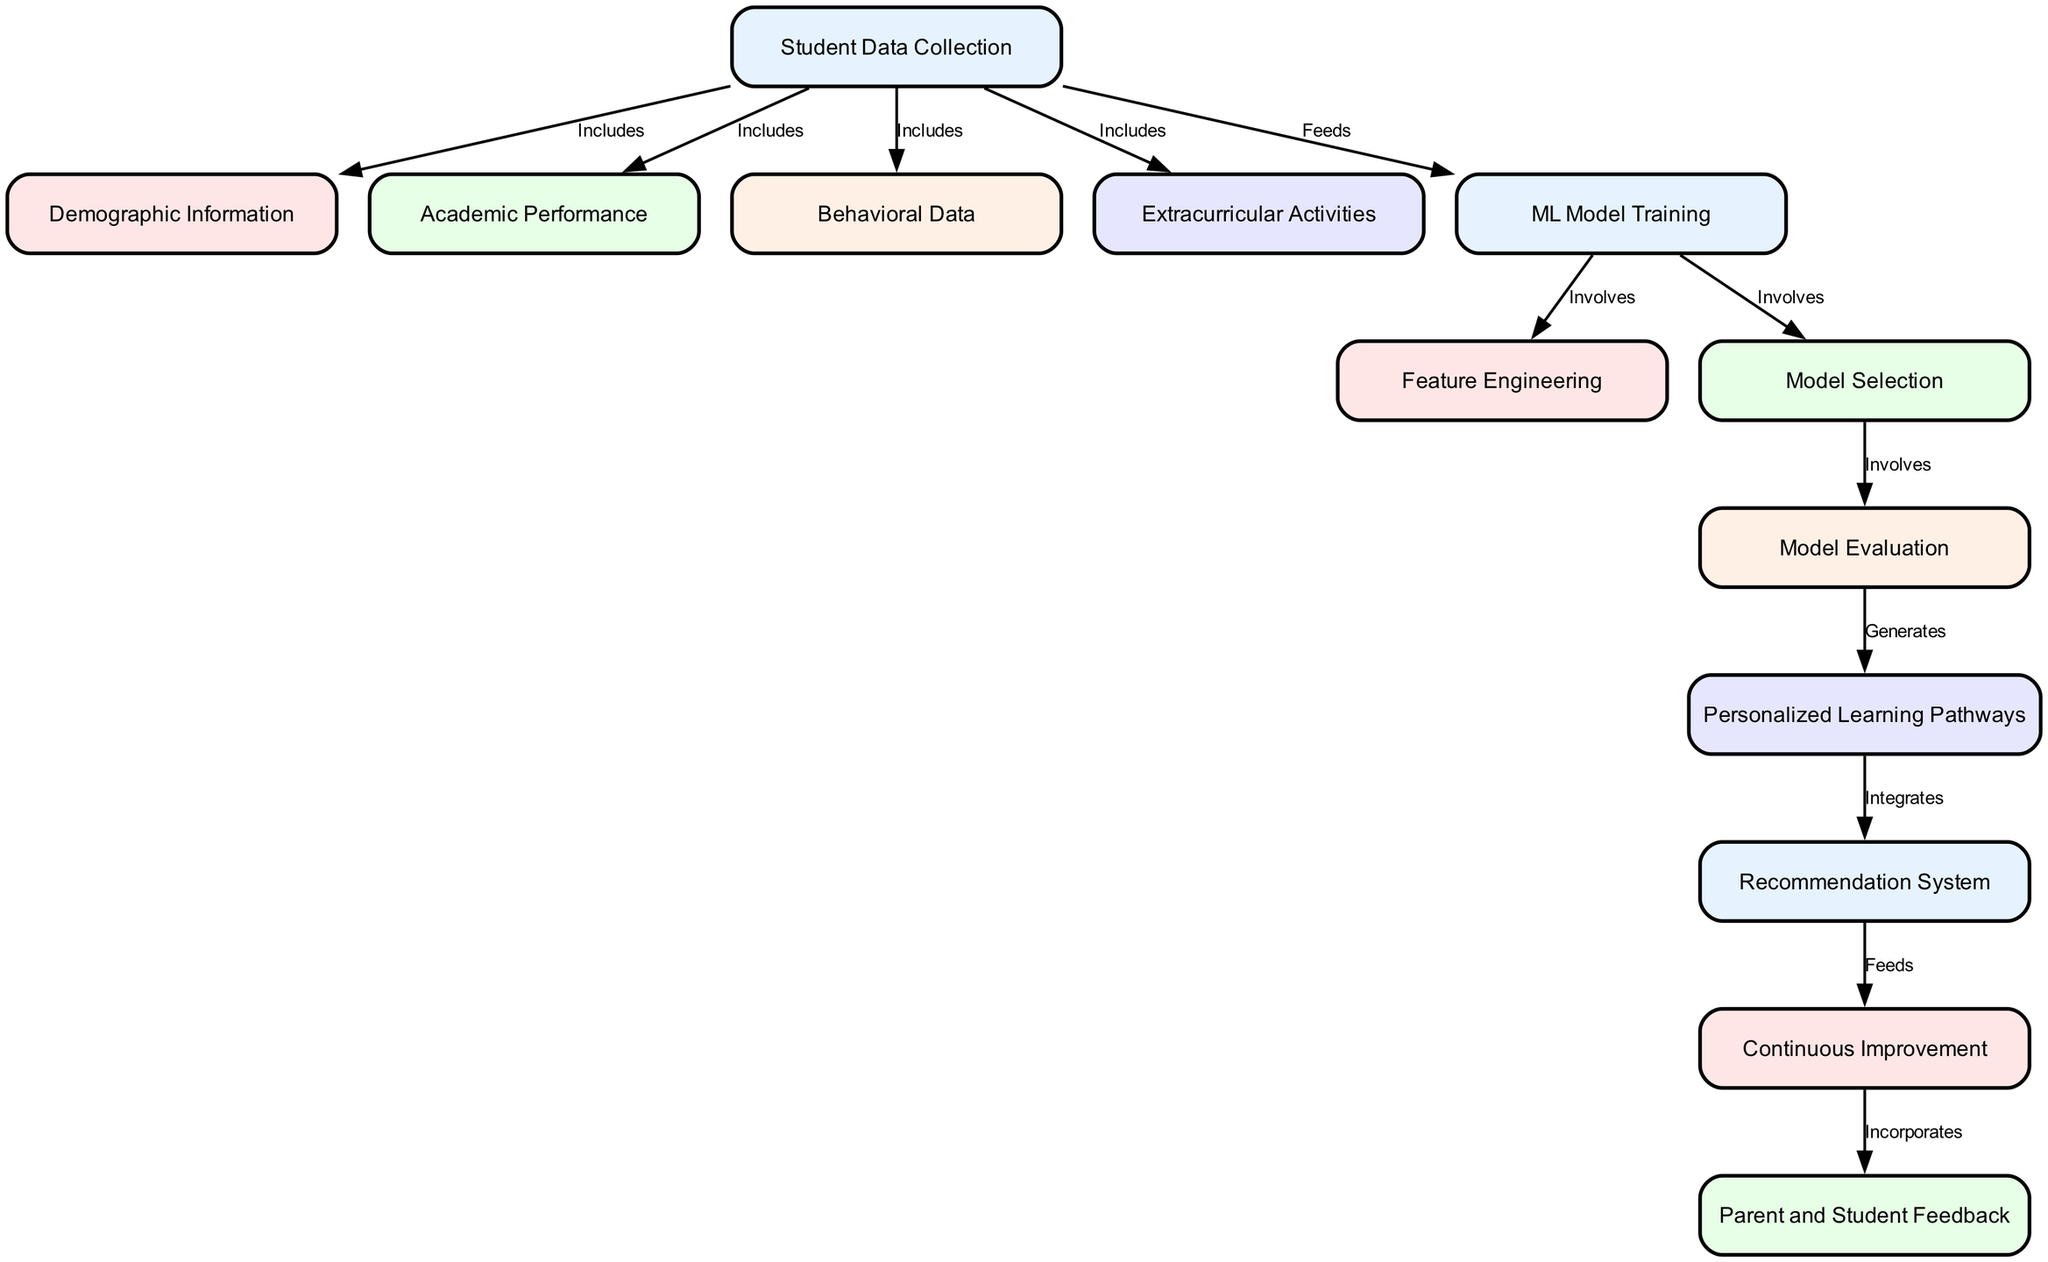What is the first node in the diagram? The first node is "Student Data Collection," which is the starting point of the entire process. This is evident as it has no predecessor nodes and is a primary input node in the diagram.
Answer: Student Data Collection How many nodes are there in the diagram? By counting each node listed in the diagram, we find a total of 13 nodes. Each node represents a different aspect of the personalized learning pathways recommendation system.
Answer: 13 What type of data does the "Student Data Collection" node include? The "Student Data Collection" node includes multiple types of data, specifically demographic information, academic performance, behavioral data, and extracurricular activities, as indicated by the connections leading from it.
Answer: Includes demographic information, academic performance, behavioral data, extracurricular activities Which node is connected to "Model Evaluation"? The "Model Evaluation" node is connected to the "Model Selection" node, which precedes it. This connection suggests that model evaluation occurs following model selection in the workflow.
Answer: Model Selection What is the role of the "Recommendation System" in the context of this diagram? The "Recommendation System" integrates with the "Personalized Learning Pathways" node and serves as a crucial component that enables the tailoring of educational plans based on the processed data. This indicates that it plays a critical role in applying the model's output to generate recommendations for students.
Answer: Integrates Personalized Learning Pathways Which nodes are involved in model training? The nodes involved in model training are "ML Model Training," "Feature Engineering," and "Model Selection." These nodes collectively represent the steps taken to prepare and refine the machine learning model used for recommendations.
Answer: ML Model Training, Feature Engineering, Model Selection What is the outcome of the "Model Evaluation" node? The outcome of the "Model Evaluation" node is "Personalized Learning Pathways." This signifies that after a model is evaluated, it generates customized educational plans tailored to individual student needs.
Answer: Generates Personalized Learning Pathways How does "Continuous Improvement" relate to feedback in the diagram? "Continuous Improvement" feeds into "Parent and Student Feedback," indicating that the insights gained from feedback contribute to iterating and enhancing the learning pathways recommendation system over time. Thus, it shows a cyclical process of incorporating feedback for better outcomes.
Answer: Feeds Parent and Student Feedback 